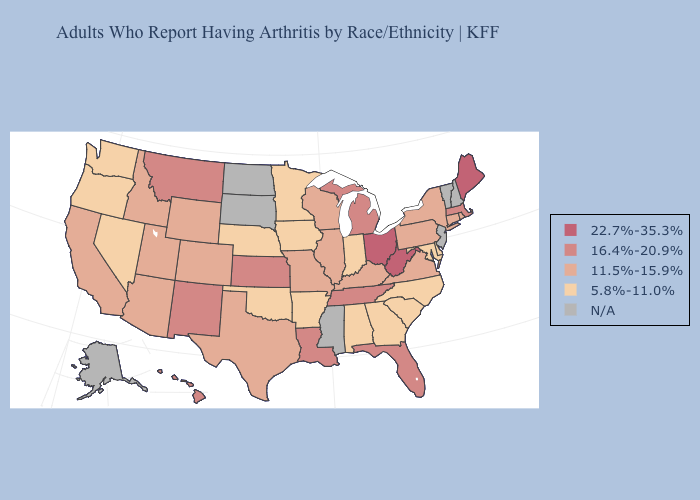Does the map have missing data?
Short answer required. Yes. What is the value of West Virginia?
Be succinct. 22.7%-35.3%. What is the lowest value in the Northeast?
Short answer required. 11.5%-15.9%. Does Massachusetts have the highest value in the Northeast?
Short answer required. No. What is the value of New Hampshire?
Concise answer only. N/A. What is the highest value in states that border Minnesota?
Quick response, please. 11.5%-15.9%. How many symbols are there in the legend?
Short answer required. 5. Name the states that have a value in the range N/A?
Concise answer only. Alaska, Mississippi, New Hampshire, New Jersey, North Dakota, South Dakota, Vermont. Name the states that have a value in the range 22.7%-35.3%?
Give a very brief answer. Maine, Ohio, West Virginia. Does the map have missing data?
Keep it brief. Yes. Among the states that border Connecticut , does Rhode Island have the lowest value?
Keep it brief. Yes. Does the map have missing data?
Write a very short answer. Yes. Name the states that have a value in the range N/A?
Concise answer only. Alaska, Mississippi, New Hampshire, New Jersey, North Dakota, South Dakota, Vermont. 